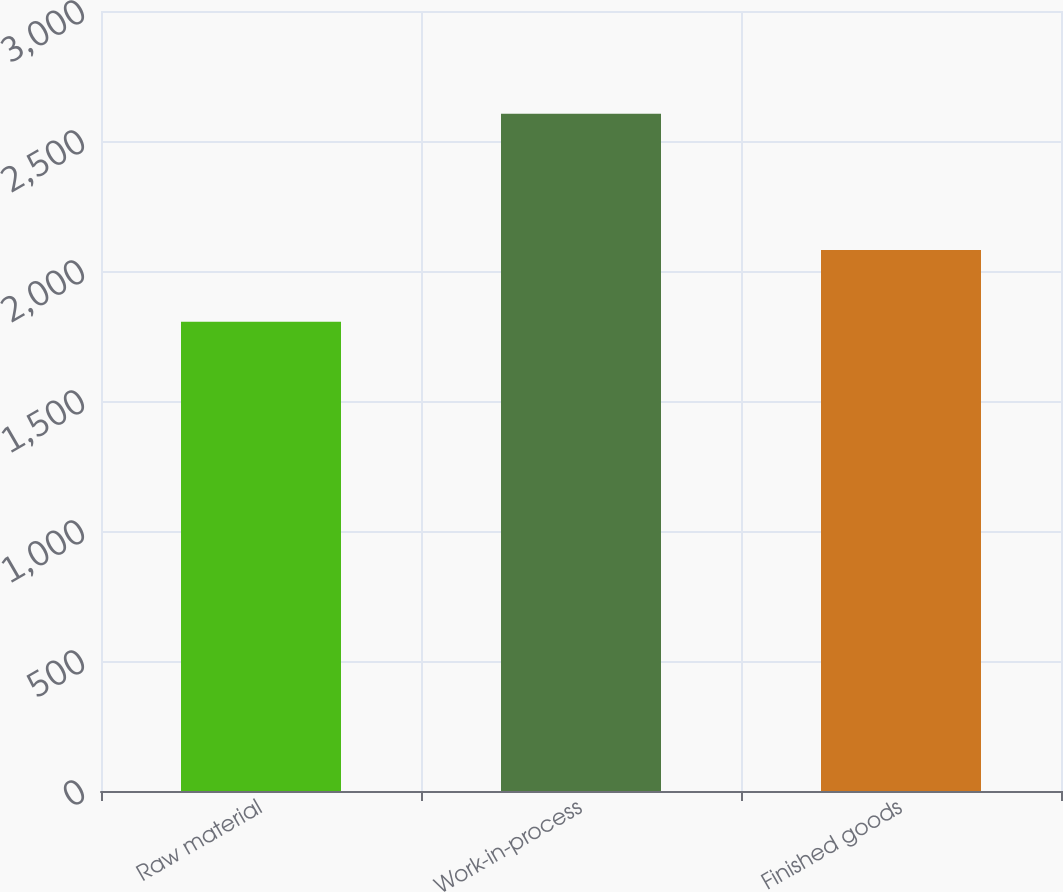Convert chart to OTSL. <chart><loc_0><loc_0><loc_500><loc_500><bar_chart><fcel>Raw material<fcel>Work-in-process<fcel>Finished goods<nl><fcel>1805<fcel>2605<fcel>2081<nl></chart> 